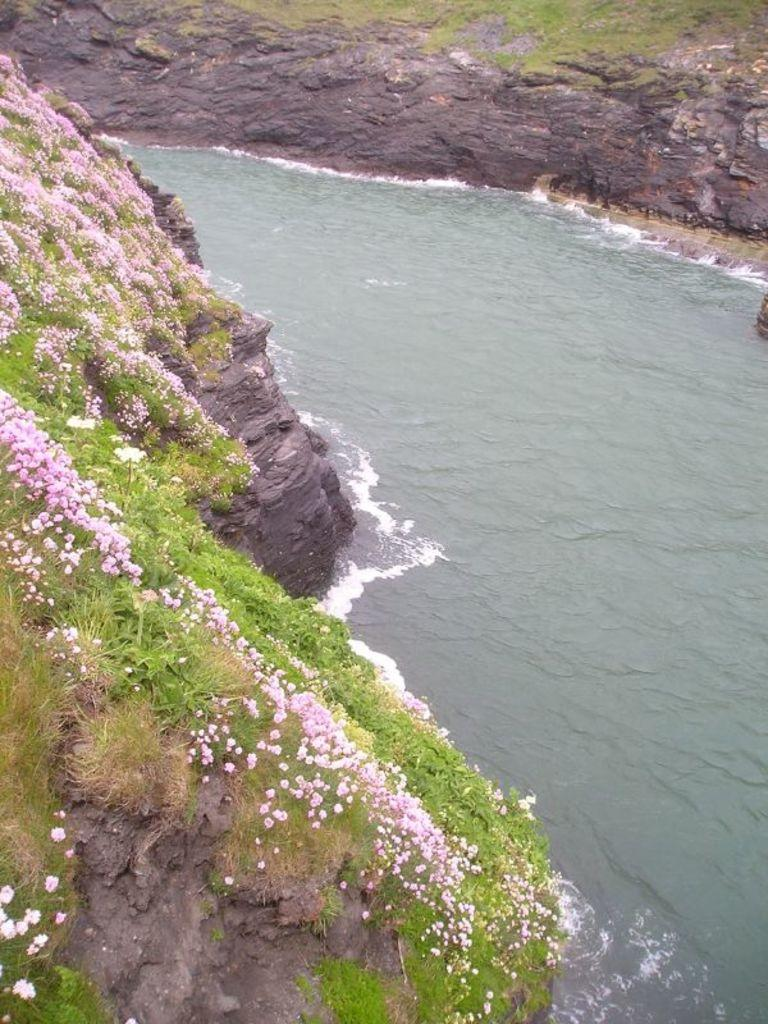What is the main feature in the center of the image? There is a river in the center of the image. What can be seen on the left side of the image? There are plants with flowers on the left side of the image. What is present on the right side of the image? There are rocks on the right side of the image. What type of lunch is being prepared on the rocks in the image? There is no lunch or any indication of food preparation in the image; it features a river, plants with flowers, and rocks. 